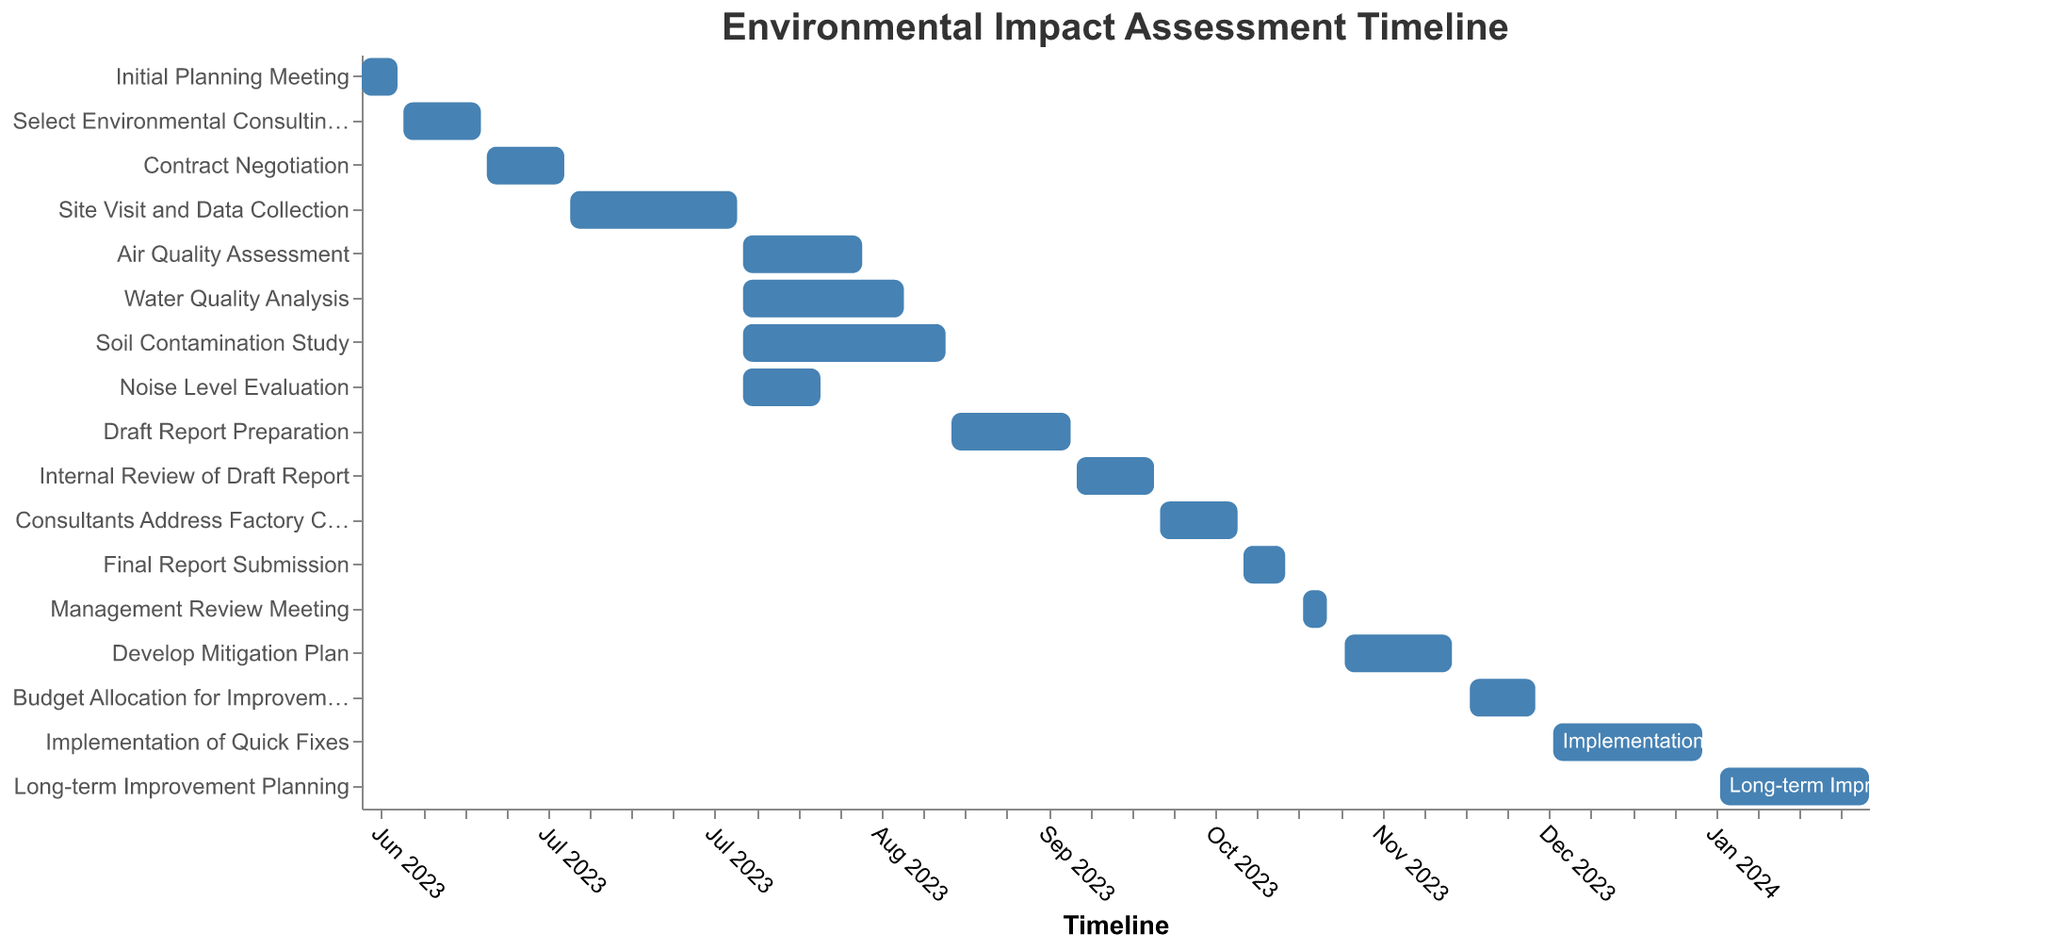What is the duration of the "Contract Negotiation" task? To find the duration, we subtract the start date from the end date. Contract Negotiation starts on 2023-06-22 and ends on 2023-07-05. So, the duration is from June 22 to July 5, which is 14 days
Answer: 14 days Which task spans the longest period? To determine the task with the longest period, we identify the start and end dates for each task and calculate the duration. "Develop Mitigation Plan" starts on 2023-11-13 and ends on 2023-12-01, lasting 19 days. Other durations are shorter
Answer: Develop Mitigation Plan What tasks overlap during the month of August 2023? Tasks overlapping in August 2023 include Air Quality Assessment (Aug 4 - Aug 24), Water Quality Analysis (Aug 4 - Aug 31), Soil Contamination Study (Aug 4 - Sep 7), and Noise Level Evaluation (Aug 4 - Aug 17)
Answer: Air Quality Assessment, Water Quality Analysis, Soil Contamination Study, Noise Level Evaluation What is the total duration covered by the entire project? The whole project starts on 2023-06-01 and ends on 2024-02-09. Therefore, the total duration spans from June 1, 2023, to February 9, 2024, which is approximately 254 days
Answer: 254 days Which task concludes right before the "Consultants Address Factory Concerns" task starts? The task "Internal Review of Draft Report" ends on 2023-10-12, which is directly before "Consultants Address Factory Concerns" starts on 2023-10-13
Answer: Internal Review of Draft Report How many tasks are planned after the final report submission? "Final Report Submission" ends on 2023-11-03. Following this, the tasks are Management Review Meeting, Develop Mitigation Plan, Budget Allocation for Improvements, Implementation of Quick Fixes, and Long-term Improvement Planning, making 5 tasks
Answer: 5 tasks Which tasks begin in June 2023? The tasks beginning in June 2023 are Initial Planning Meeting (starts on 2023-06-01) and Select Environmental Consulting Firm (starts on 2023-06-08)
Answer: Initial Planning Meeting, Select Environmental Consulting Firm What are the starting and ending dates of the "Long-term Improvement Planning" task? The "Long-term Improvement Planning" task starts on 2024-01-15 and ends on 2024-02-09 as shown in the figure
Answer: 2024-01-15 to 2024-02-09 What is the duration of the "Develop Mitigation Plan" task in weeks? "Develop Mitigation Plan" begins on 2023-11-13 and ends on 2023-12-01. From November 13 to December 1 is 19 days. Converting days to weeks: 19/7 = ~2.71 weeks
Answer: Approximately 2.71 weeks Which tasks are tagged with the color white text? The tasks tagged with white text are "Implementation of Quick Fixes" and "Long-term Improvement Planning" as indicated in the figure
Answer: Implementation of Quick Fixes, Long-term Improvement Planning 